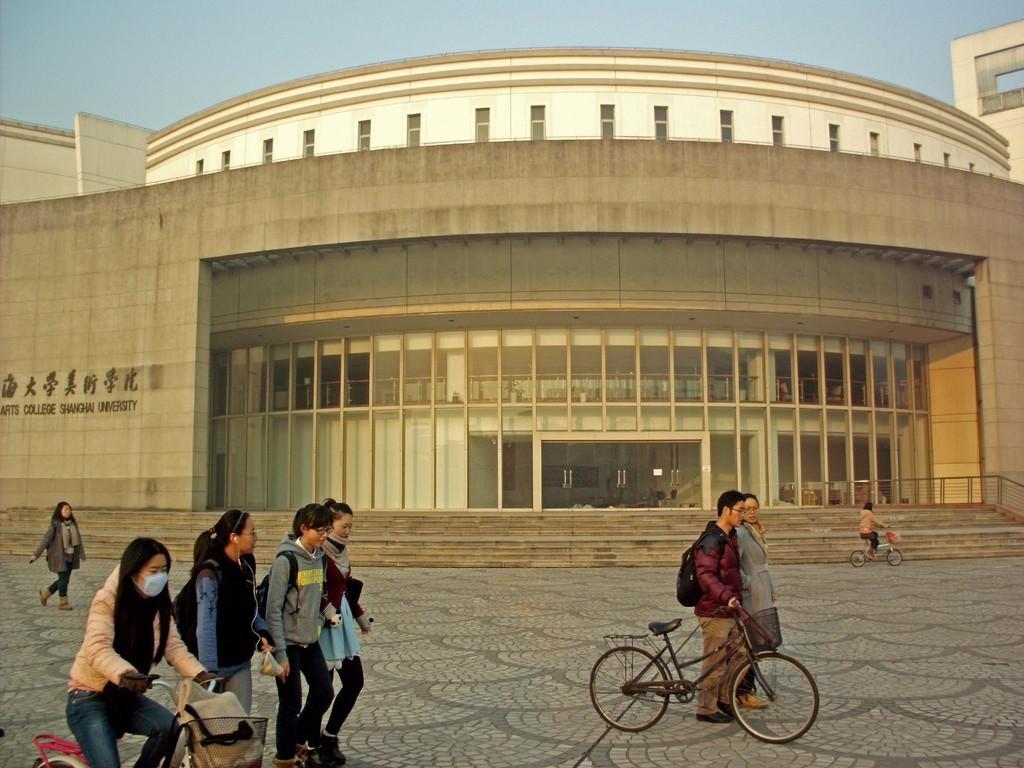Could you give a brief overview of what you see in this image? In this picture outside of the college. There is a group of people. They are walking. On the left side we have a woman. She is wearing a mask. She is riding a bicycle. On the right side we have a two persons. They are standing. They are wearing a bag. We can see in background building and sky. 